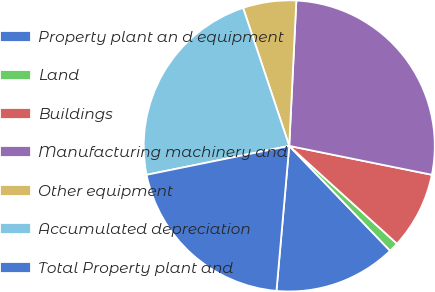Convert chart to OTSL. <chart><loc_0><loc_0><loc_500><loc_500><pie_chart><fcel>Property plant an d equipment<fcel>Land<fcel>Buildings<fcel>Manufacturing machinery and<fcel>Other equipment<fcel>Accumulated depreciation<fcel>Total Property plant and<nl><fcel>13.59%<fcel>1.08%<fcel>8.55%<fcel>27.4%<fcel>5.91%<fcel>23.05%<fcel>20.42%<nl></chart> 